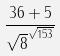<formula> <loc_0><loc_0><loc_500><loc_500>\frac { 3 6 + 5 } { \sqrt { 8 } ^ { \sqrt { 1 5 3 } } }</formula> 